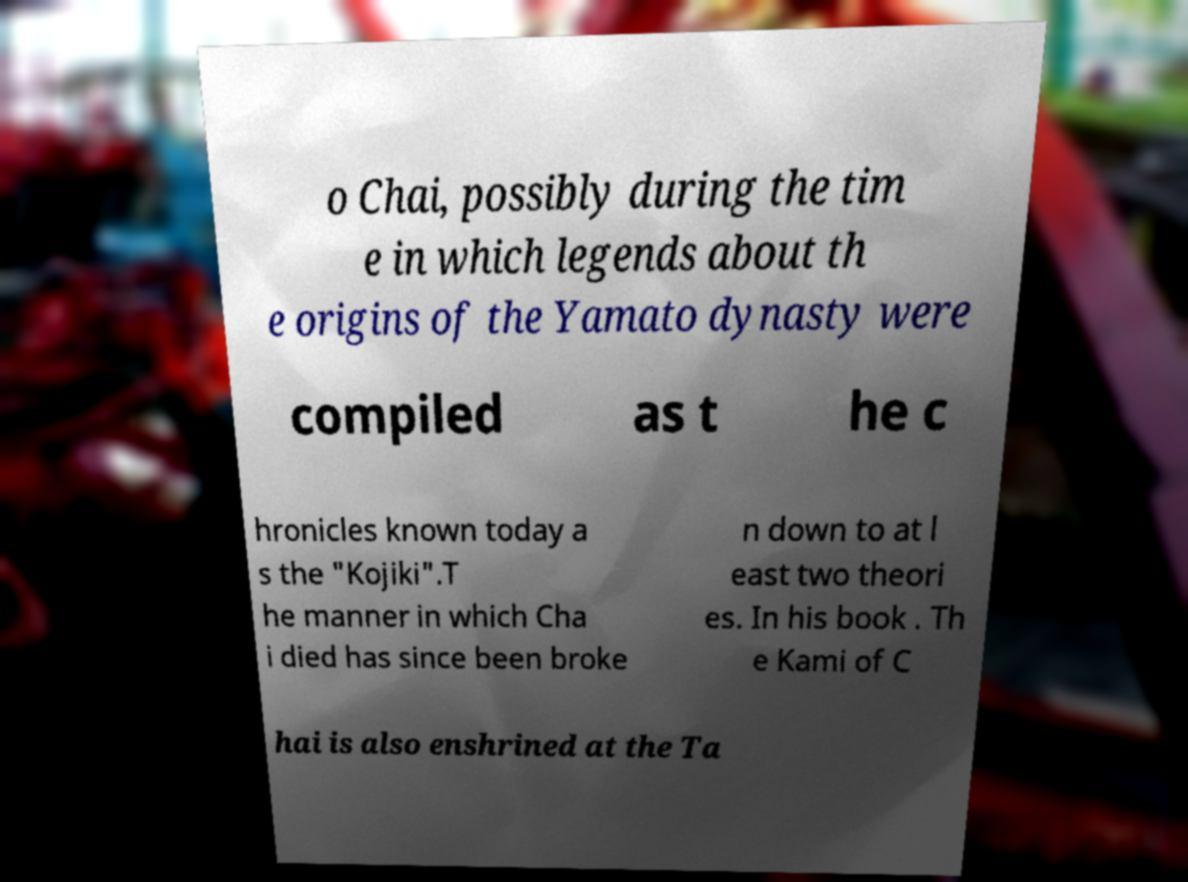Could you assist in decoding the text presented in this image and type it out clearly? o Chai, possibly during the tim e in which legends about th e origins of the Yamato dynasty were compiled as t he c hronicles known today a s the "Kojiki".T he manner in which Cha i died has since been broke n down to at l east two theori es. In his book . Th e Kami of C hai is also enshrined at the Ta 